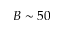<formula> <loc_0><loc_0><loc_500><loc_500>B \sim 5 0</formula> 